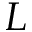Convert formula to latex. <formula><loc_0><loc_0><loc_500><loc_500>L</formula> 